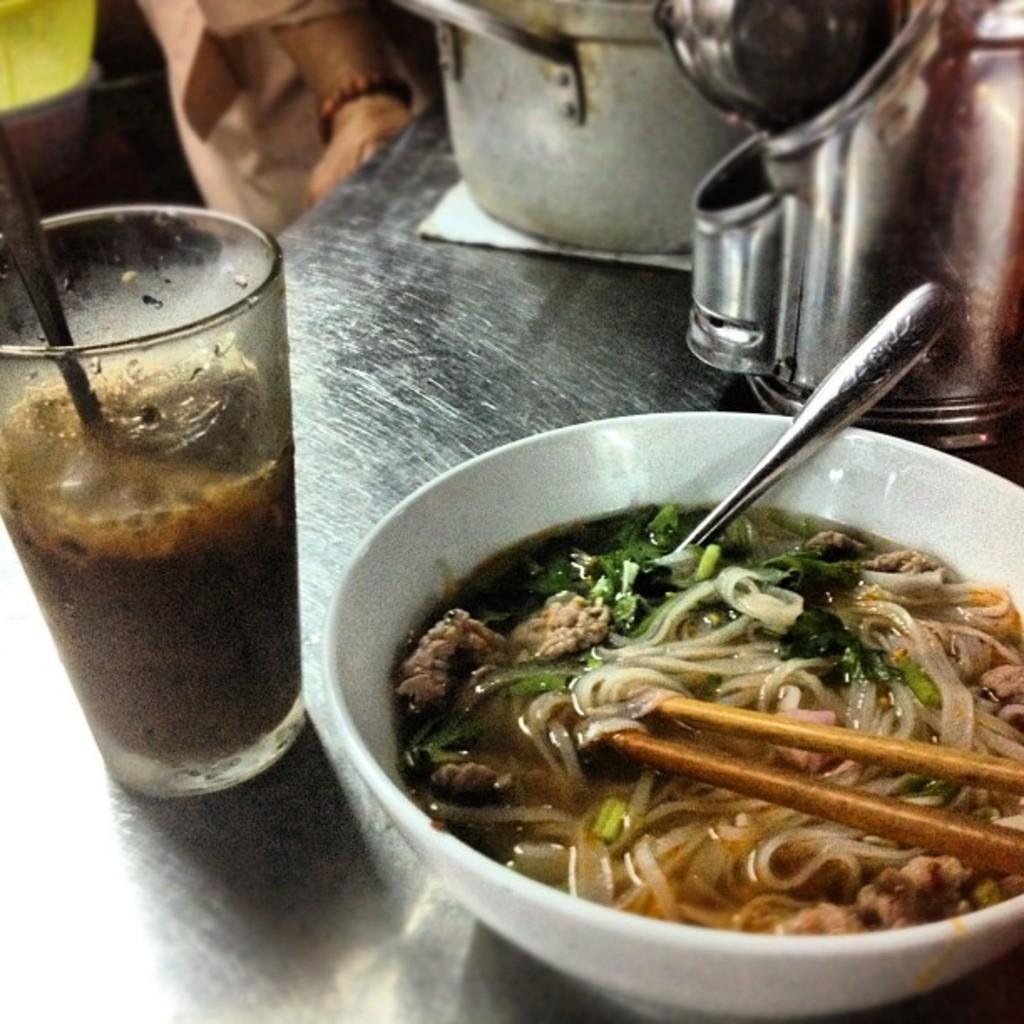How would you summarize this image in a sentence or two? In this picture we can see a table,on this table we can see bowls,glass,food items. 